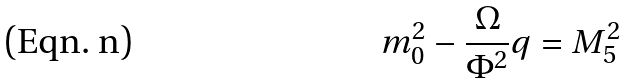Convert formula to latex. <formula><loc_0><loc_0><loc_500><loc_500>m _ { 0 } ^ { 2 } - \frac { \Omega } { \Phi ^ { 2 } } q = M _ { 5 } ^ { 2 }</formula> 